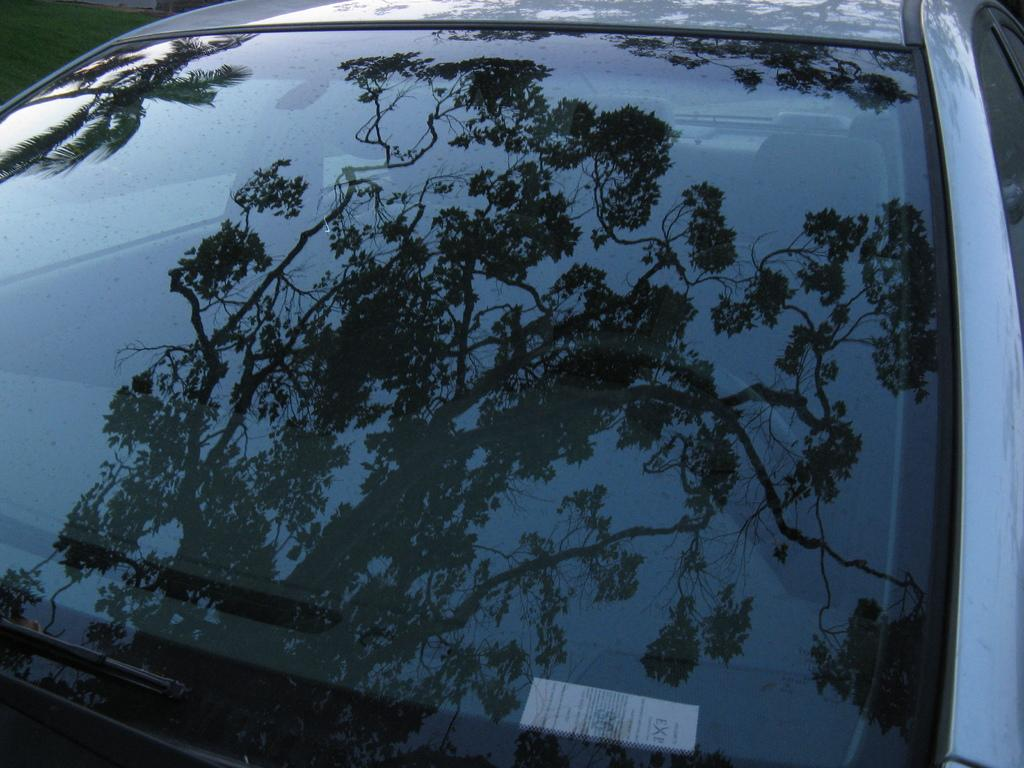What is the main subject of the image? The main subject of the image is a mirror of a car. What can be seen in the car's mirror? There is a reflection of a tree in the car's mirror. How many rabbits are hopping across the bridge in the image? There are no rabbits or bridges present in the image; it only features a car's mirror with a tree's reflection. 